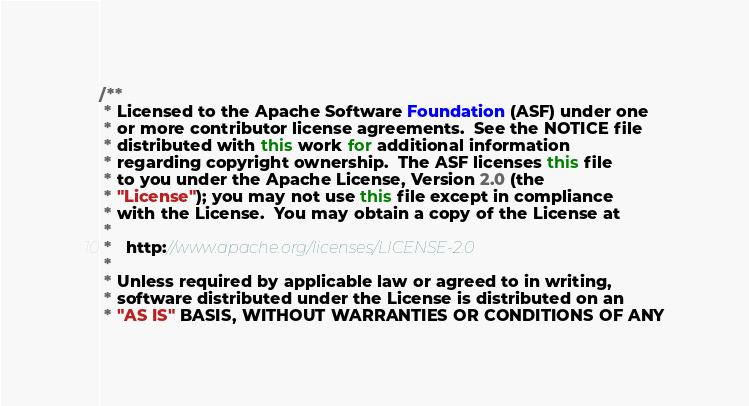<code> <loc_0><loc_0><loc_500><loc_500><_Java_>/**
 * Licensed to the Apache Software Foundation (ASF) under one
 * or more contributor license agreements.  See the NOTICE file
 * distributed with this work for additional information
 * regarding copyright ownership.  The ASF licenses this file
 * to you under the Apache License, Version 2.0 (the
 * "License"); you may not use this file except in compliance
 * with the License.  You may obtain a copy of the License at
 *
 *   http://www.apache.org/licenses/LICENSE-2.0
 *
 * Unless required by applicable law or agreed to in writing,
 * software distributed under the License is distributed on an
 * "AS IS" BASIS, WITHOUT WARRANTIES OR CONDITIONS OF ANY</code> 